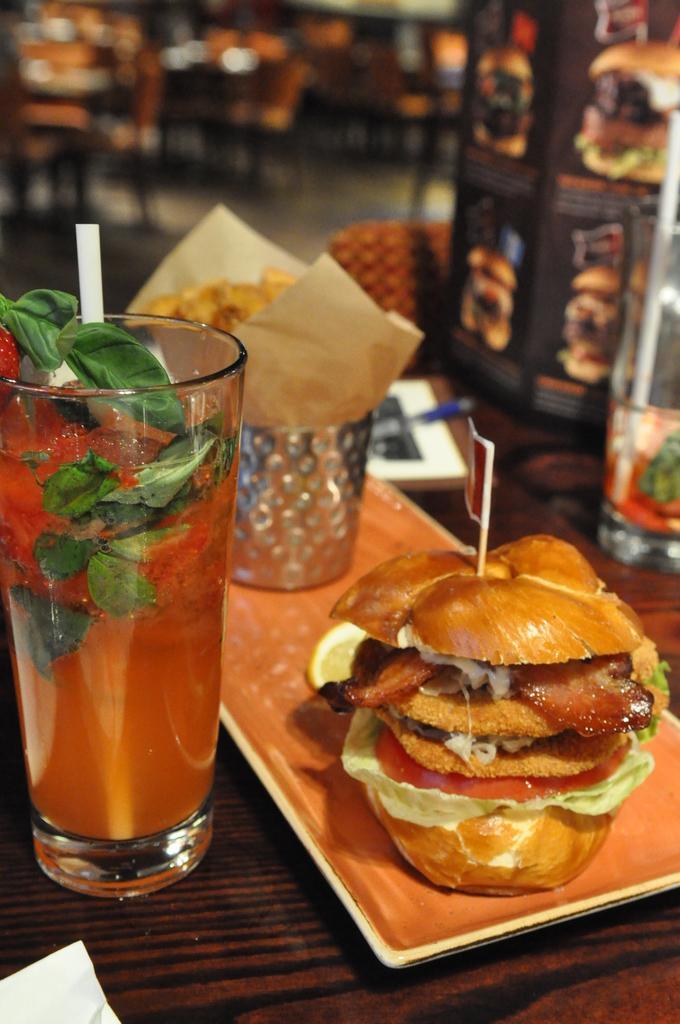Can you describe this image briefly? In this picture there is a table on which some food was placed in the plate. There is a glass with some drink in it. In the right side there is a bottle on the table. The table is in brown color. In the background there are tables and chairs. 